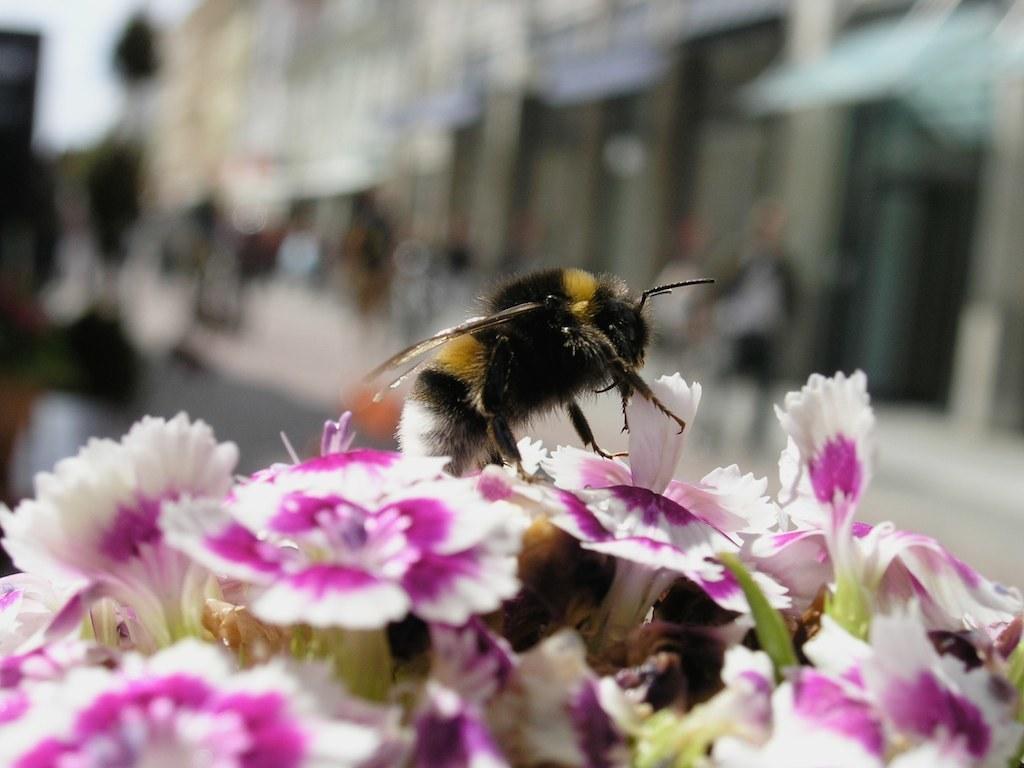Can you describe this image briefly? In this picture we can see an insect on the flowers and the flowers are in white and purple colors. Behind the insect there is a blurred background. 